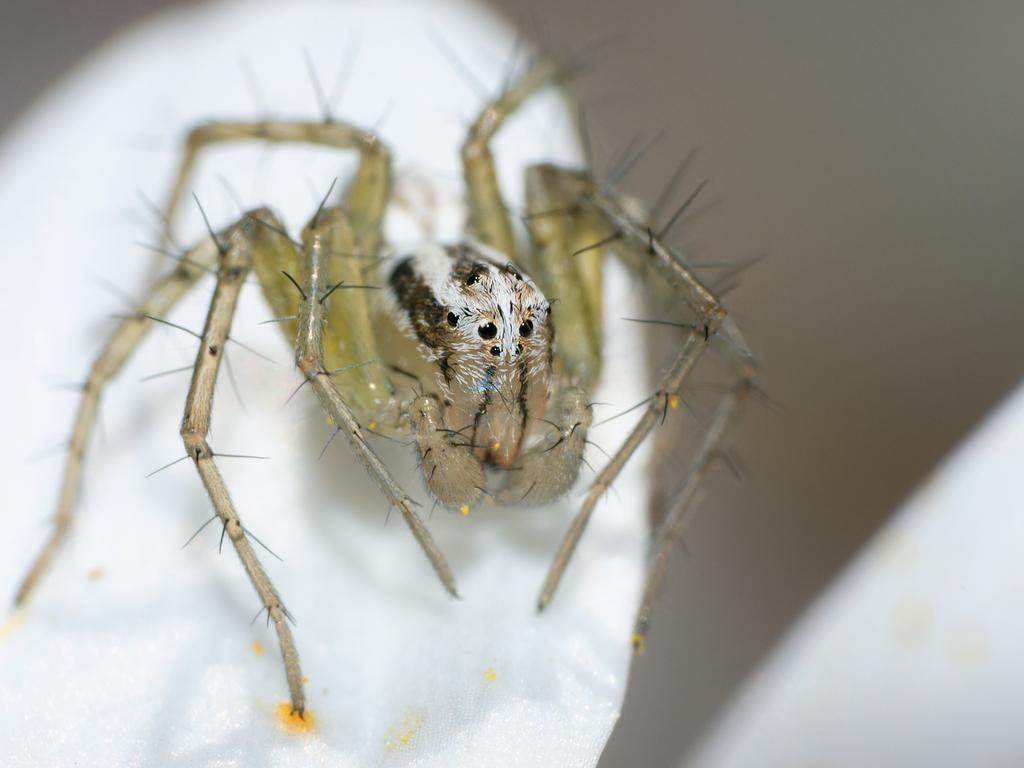What type of creature is present in the image? There is an insect in the image. What is the insect resting on? The insect is on a white surface. What type of airplane is visible in the image? There is no airplane present in the image; it features an insect on a white surface. What color is the sock in the image? There is no sock present in the image. 